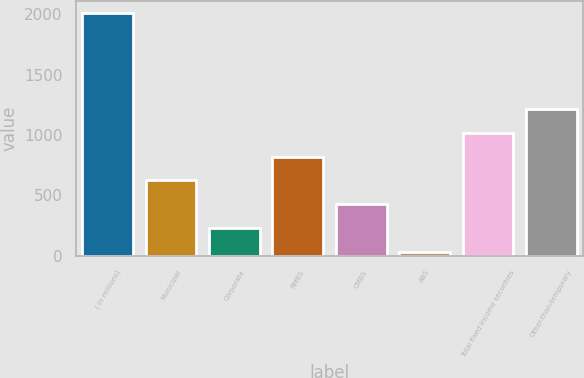<chart> <loc_0><loc_0><loc_500><loc_500><bar_chart><fcel>( in millions)<fcel>Municipal<fcel>Corporate<fcel>RMBS<fcel>CMBS<fcel>ABS<fcel>Total fixed income securities<fcel>Other-than-temporary<nl><fcel>2010<fcel>624<fcel>228<fcel>822<fcel>426<fcel>30<fcel>1020<fcel>1218<nl></chart> 